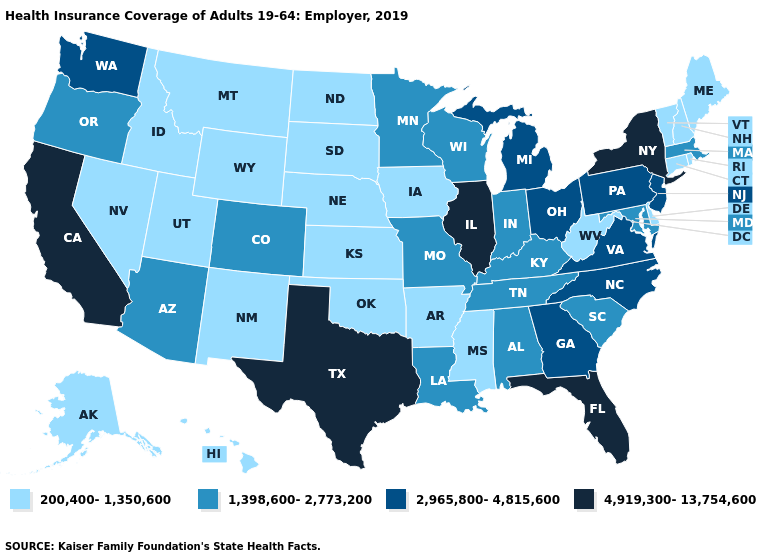Which states have the highest value in the USA?
Short answer required. California, Florida, Illinois, New York, Texas. Among the states that border Arkansas , which have the lowest value?
Be succinct. Mississippi, Oklahoma. How many symbols are there in the legend?
Concise answer only. 4. Does Mississippi have the lowest value in the USA?
Short answer required. Yes. Does the map have missing data?
Write a very short answer. No. Does South Carolina have a lower value than Florida?
Be succinct. Yes. What is the highest value in states that border West Virginia?
Quick response, please. 2,965,800-4,815,600. Name the states that have a value in the range 4,919,300-13,754,600?
Be succinct. California, Florida, Illinois, New York, Texas. What is the value of Massachusetts?
Write a very short answer. 1,398,600-2,773,200. What is the highest value in the USA?
Answer briefly. 4,919,300-13,754,600. Name the states that have a value in the range 2,965,800-4,815,600?
Be succinct. Georgia, Michigan, New Jersey, North Carolina, Ohio, Pennsylvania, Virginia, Washington. Name the states that have a value in the range 1,398,600-2,773,200?
Answer briefly. Alabama, Arizona, Colorado, Indiana, Kentucky, Louisiana, Maryland, Massachusetts, Minnesota, Missouri, Oregon, South Carolina, Tennessee, Wisconsin. Which states have the lowest value in the MidWest?
Concise answer only. Iowa, Kansas, Nebraska, North Dakota, South Dakota. What is the lowest value in states that border North Carolina?
Concise answer only. 1,398,600-2,773,200. Name the states that have a value in the range 2,965,800-4,815,600?
Short answer required. Georgia, Michigan, New Jersey, North Carolina, Ohio, Pennsylvania, Virginia, Washington. 